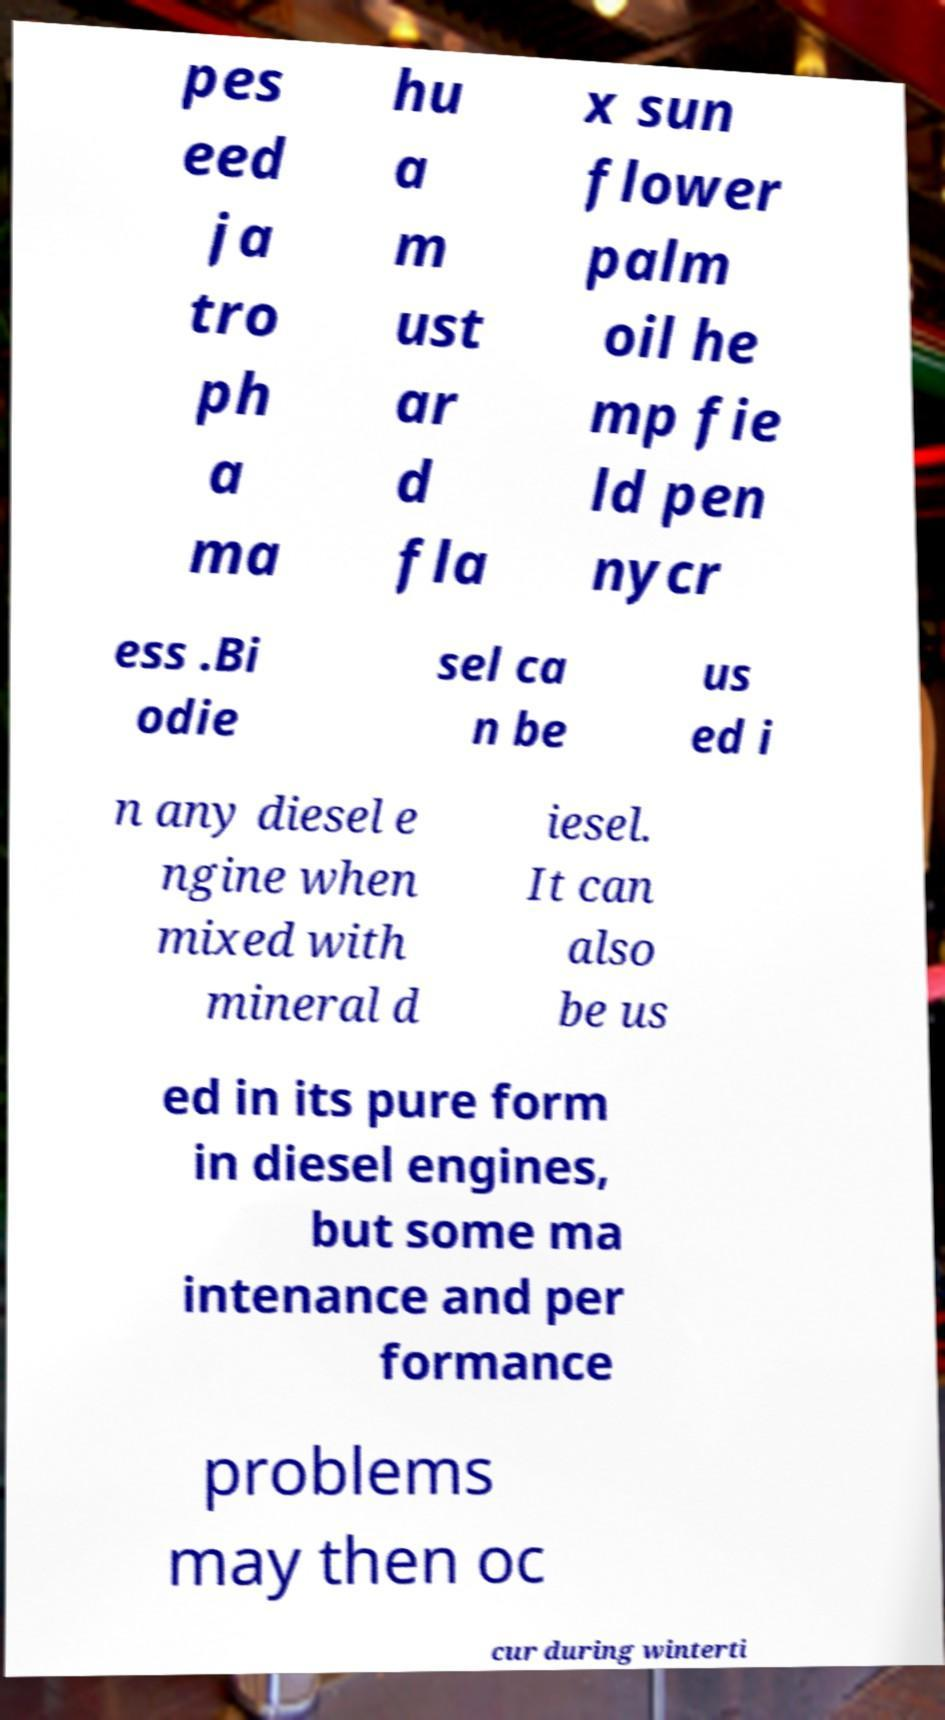Can you accurately transcribe the text from the provided image for me? pes eed ja tro ph a ma hu a m ust ar d fla x sun flower palm oil he mp fie ld pen nycr ess .Bi odie sel ca n be us ed i n any diesel e ngine when mixed with mineral d iesel. It can also be us ed in its pure form in diesel engines, but some ma intenance and per formance problems may then oc cur during winterti 